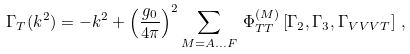Convert formula to latex. <formula><loc_0><loc_0><loc_500><loc_500>\Gamma _ { T } ( k ^ { 2 } ) = - k ^ { 2 } + \left ( \frac { g _ { 0 } } { 4 \pi } \right ) ^ { 2 } \sum _ { M = A \dots F } \, \Phi _ { T T } ^ { ( M ) } \left [ \Gamma _ { 2 } , \Gamma _ { 3 } , \Gamma _ { V V V T } \right ] \, ,</formula> 